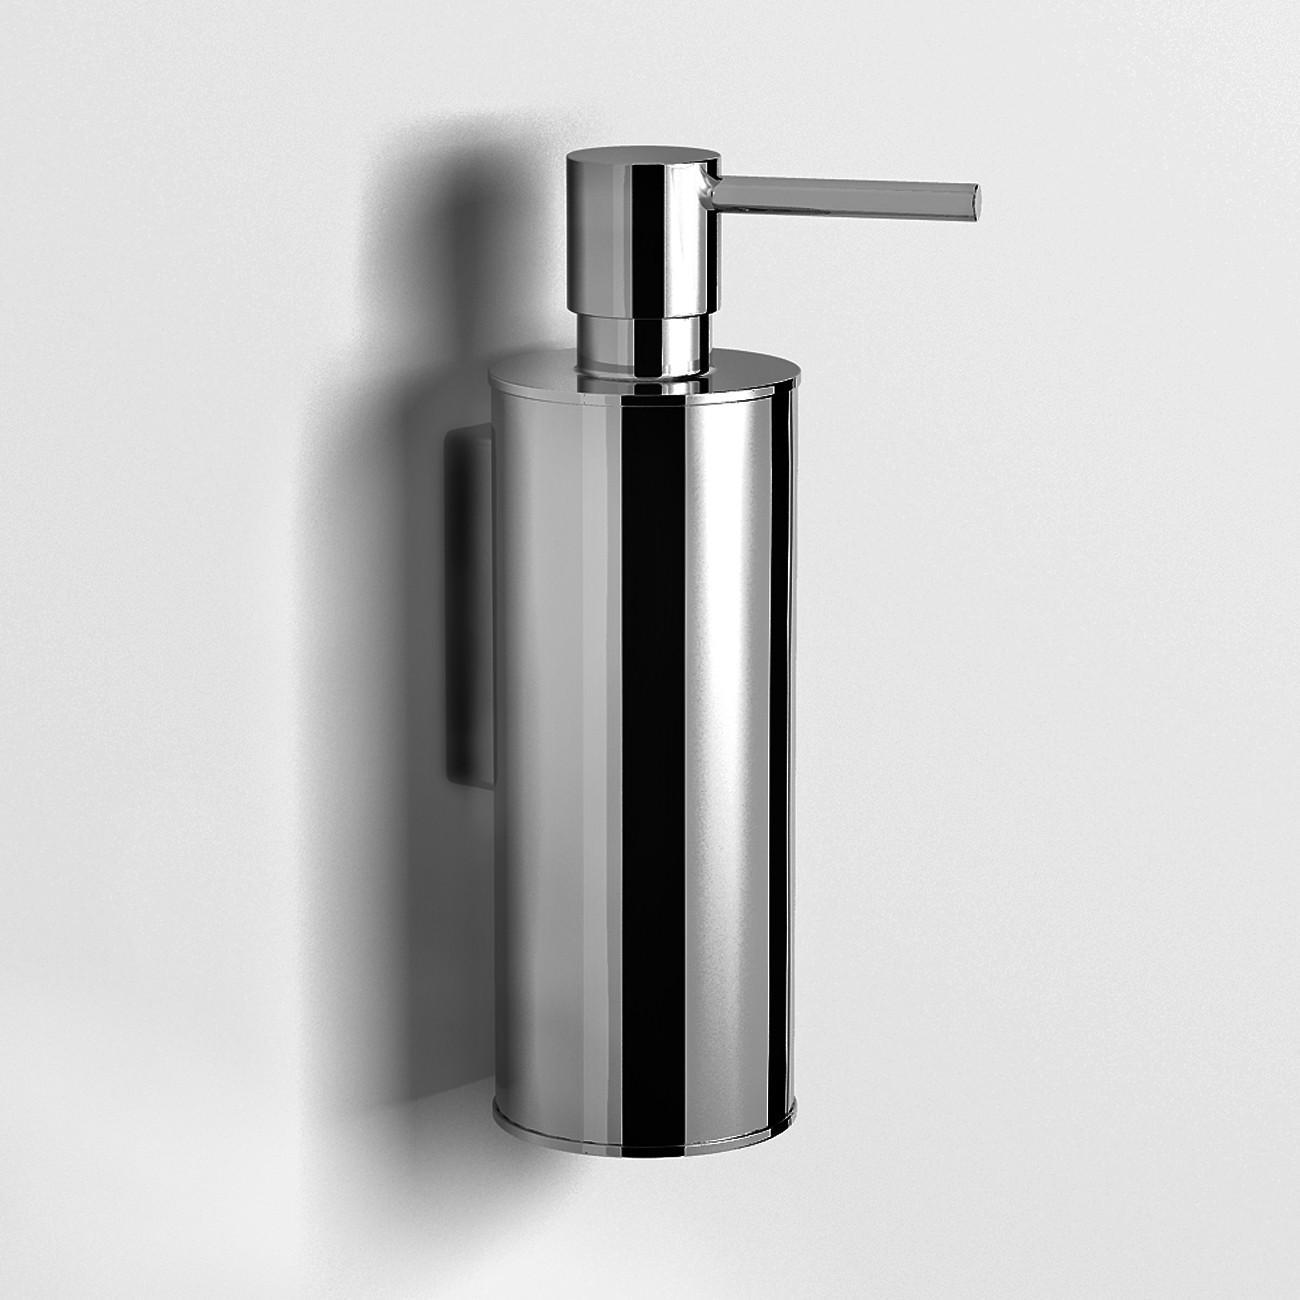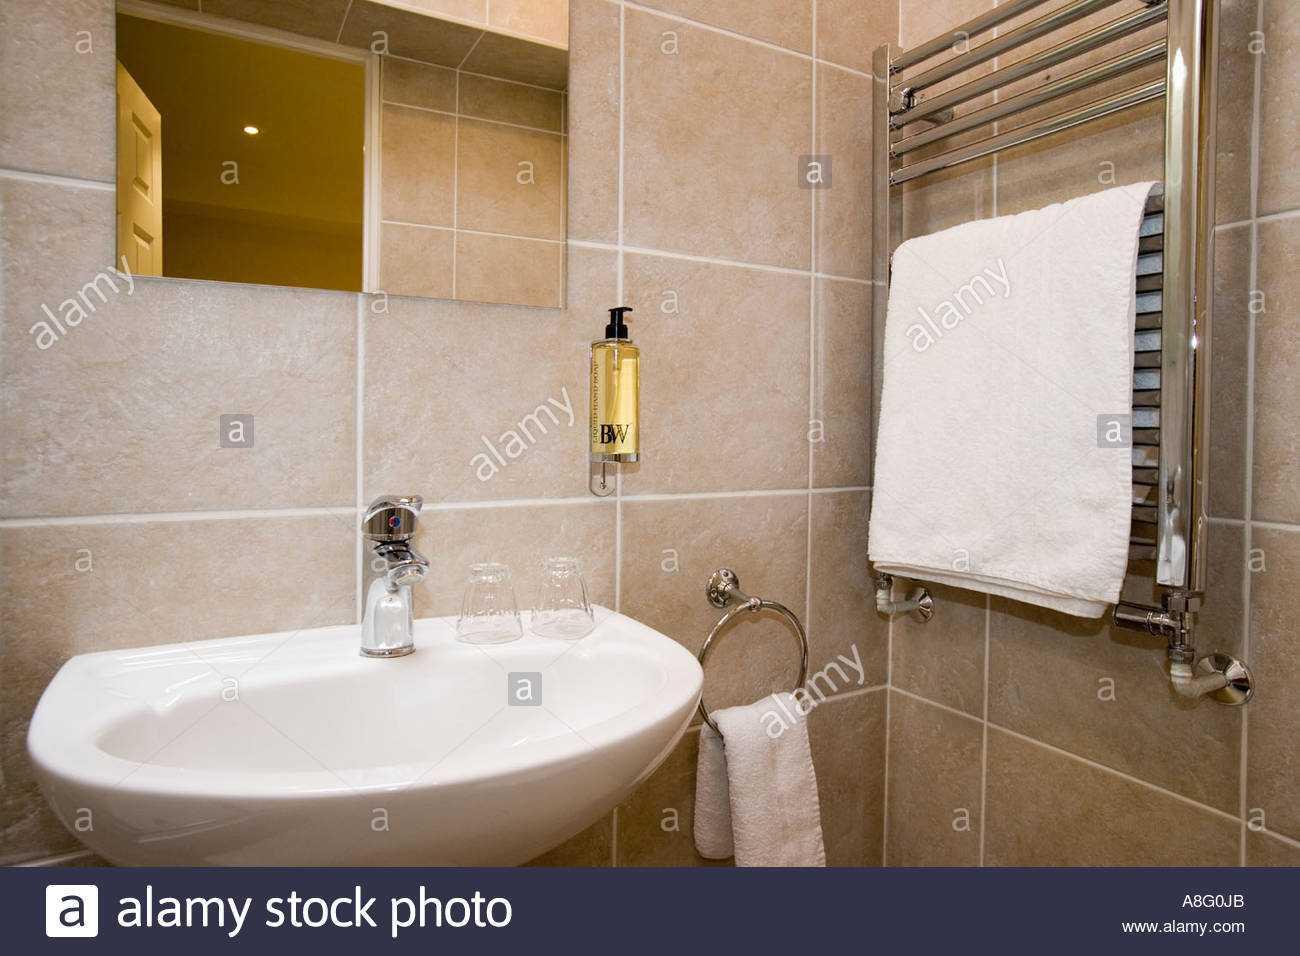The first image is the image on the left, the second image is the image on the right. Examine the images to the left and right. Is the description "there is a white square shaped sink with a chrome faucet and a vase of flowers next to it" accurate? Answer yes or no. No. The first image is the image on the left, the second image is the image on the right. Considering the images on both sides, is "The left and right image contains a total of two white square sinks." valid? Answer yes or no. No. 